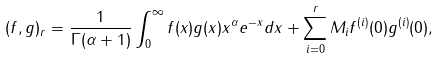<formula> <loc_0><loc_0><loc_500><loc_500>( f , g ) _ { r } = \frac { 1 } { \Gamma ( \alpha + 1 ) } \int _ { 0 } ^ { \infty } f ( x ) g ( x ) x ^ { \alpha } e ^ { - x } d x + \sum _ { i = 0 } ^ { r } M _ { i } f ^ { ( i ) } ( 0 ) g ^ { ( i ) } ( 0 ) ,</formula> 